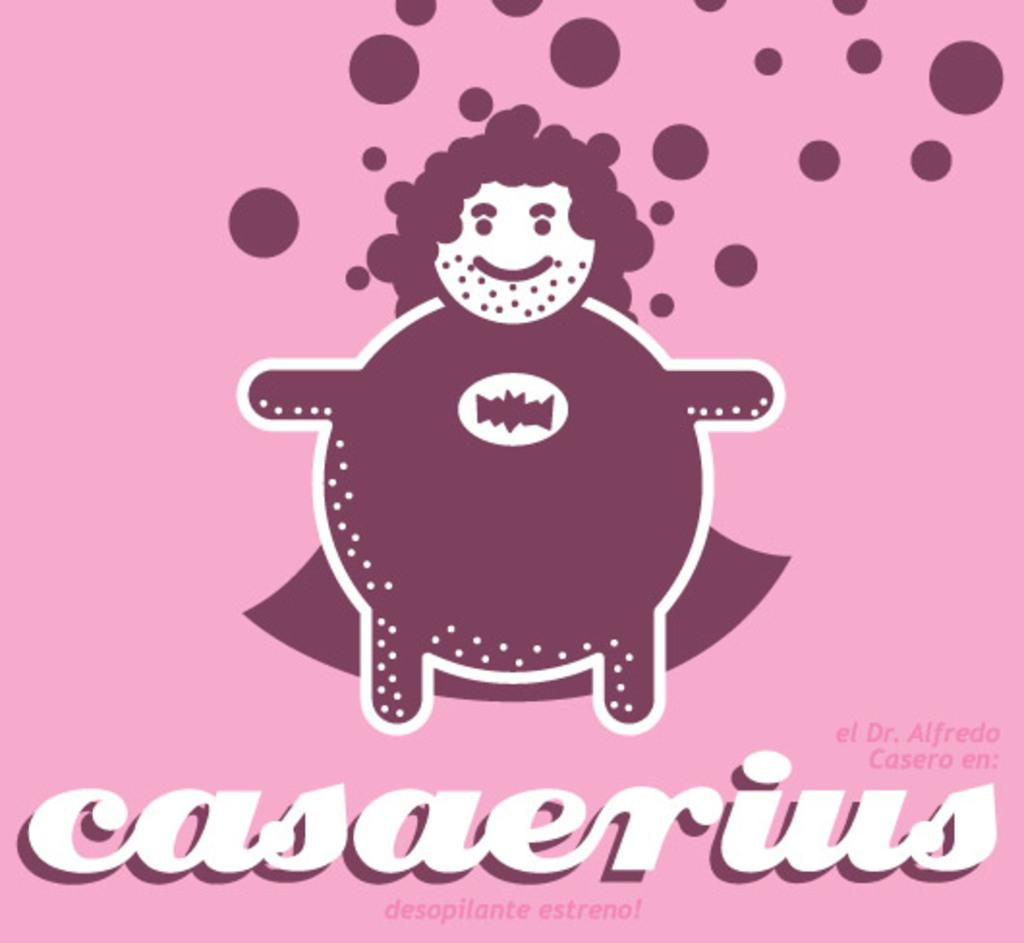<image>
Offer a succinct explanation of the picture presented. A fat man dressed like a superhero is casaerius. 